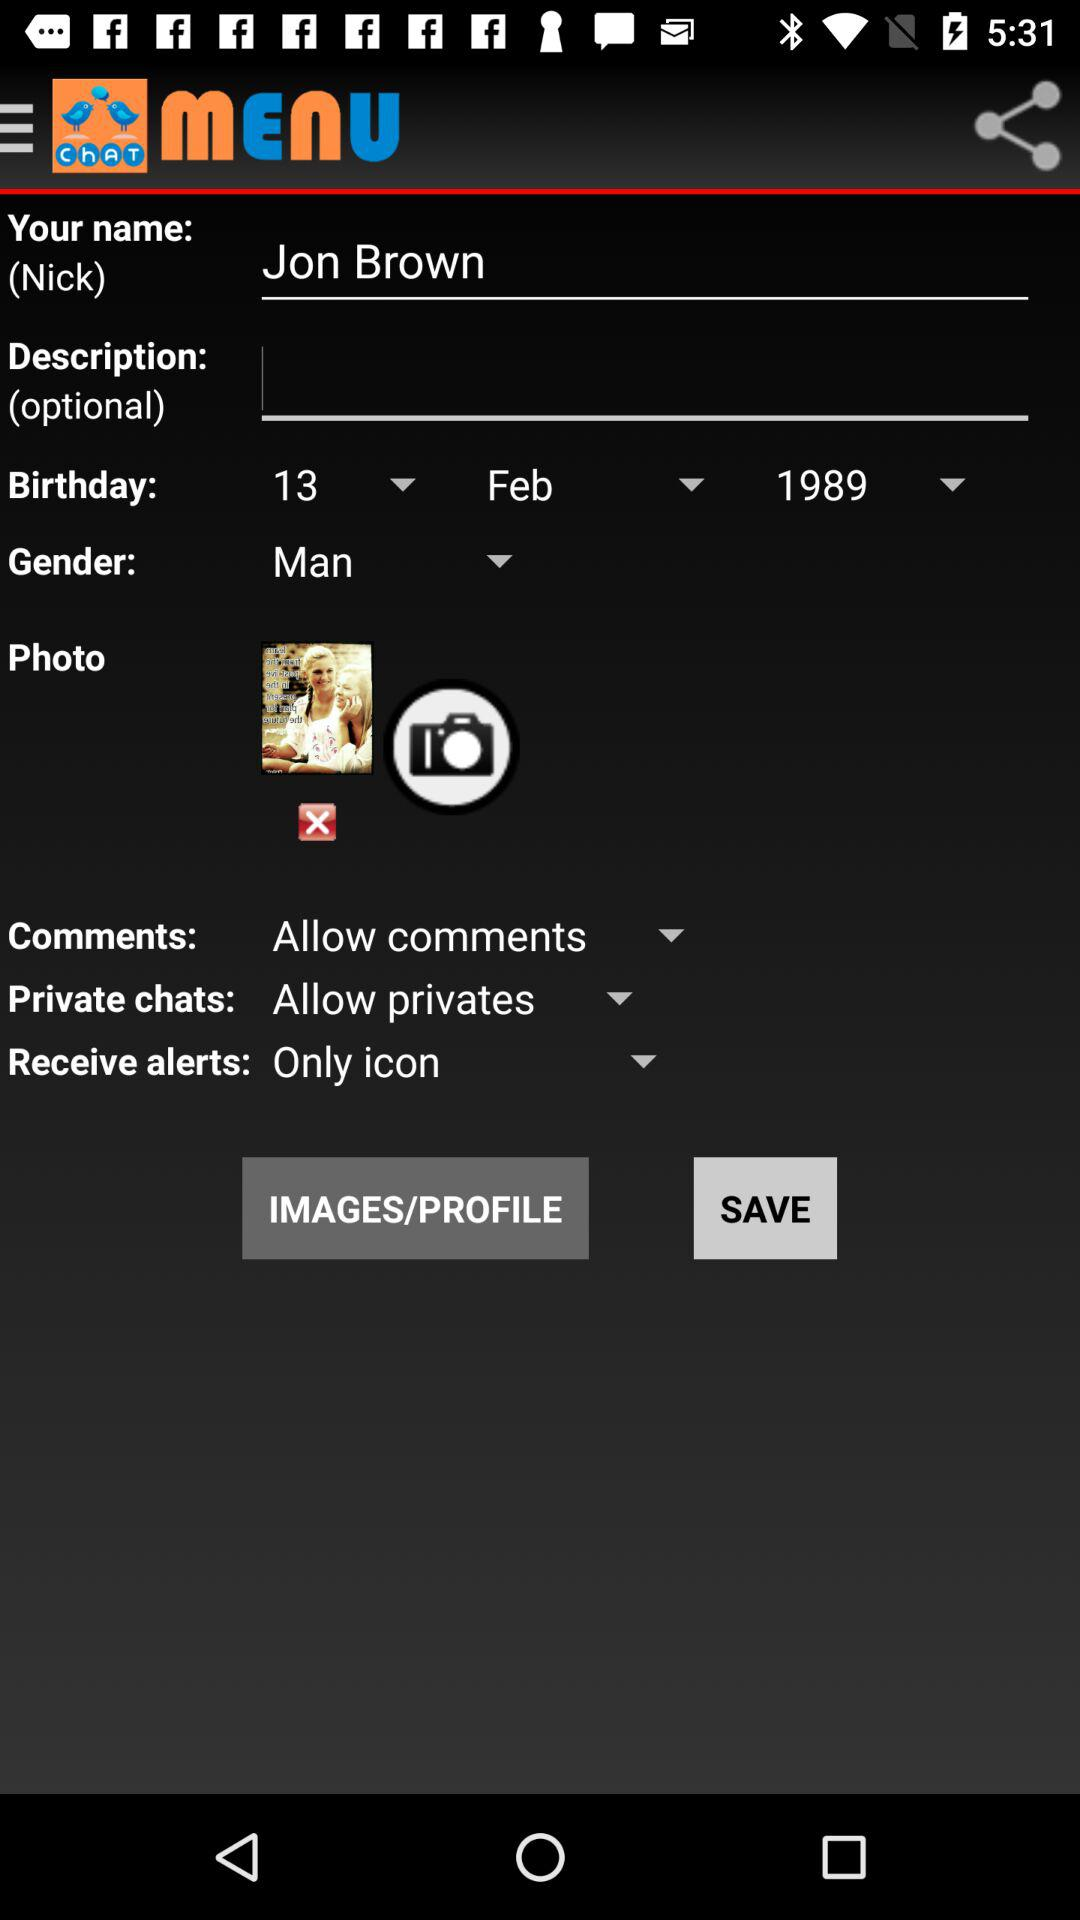What is the gender? The user is a man. 